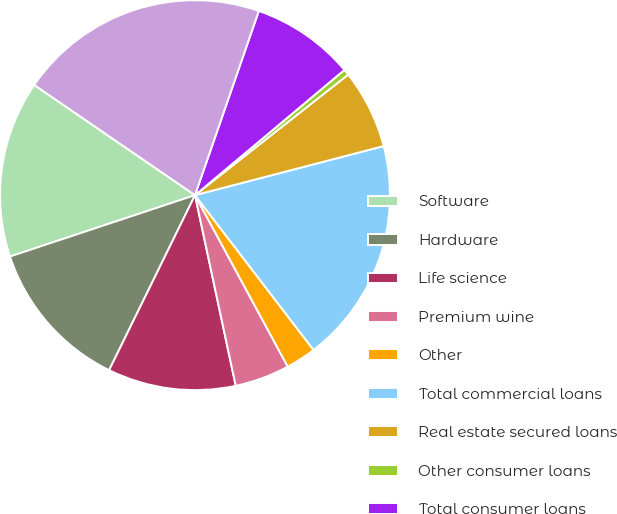Convert chart. <chart><loc_0><loc_0><loc_500><loc_500><pie_chart><fcel>Software<fcel>Hardware<fcel>Life science<fcel>Premium wine<fcel>Other<fcel>Total commercial loans<fcel>Real estate secured loans<fcel>Other consumer loans<fcel>Total consumer loans<fcel>Total gross loans<nl><fcel>14.66%<fcel>12.64%<fcel>10.61%<fcel>4.54%<fcel>2.51%<fcel>18.65%<fcel>6.56%<fcel>0.49%<fcel>8.59%<fcel>20.74%<nl></chart> 